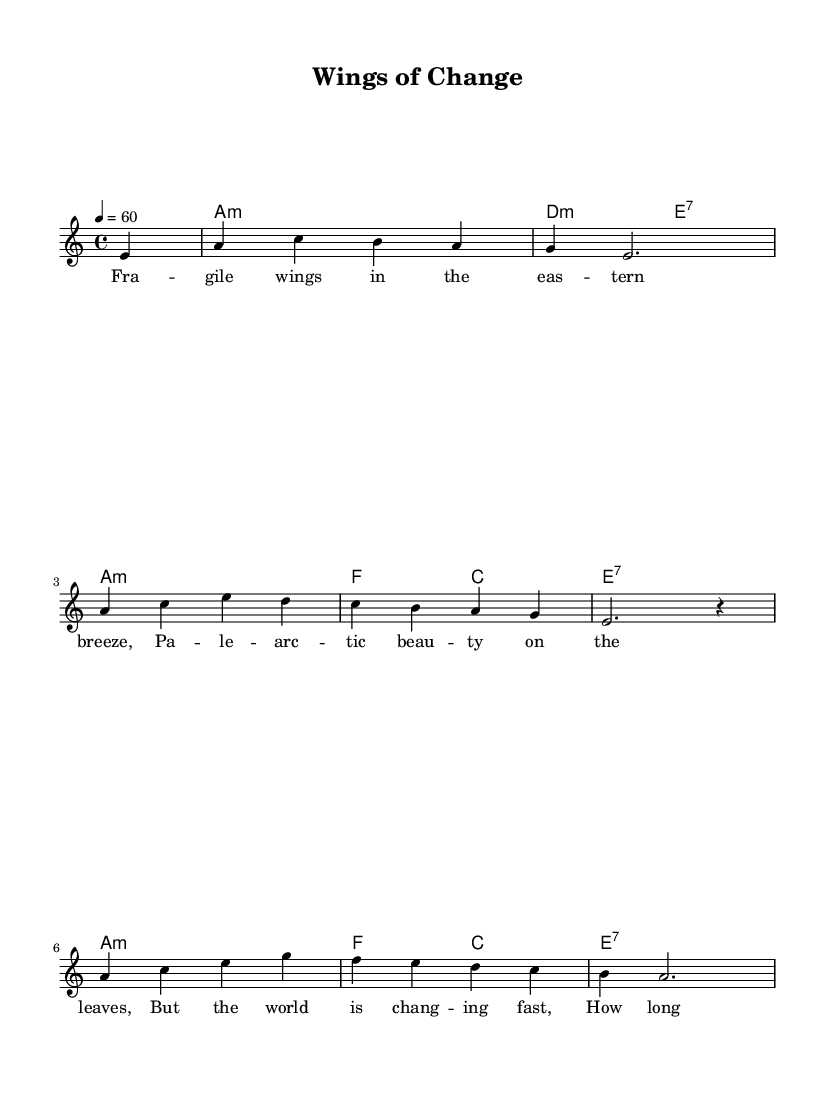What is the key signature of this music? The key signature can be determined from the information in the global section, which states "a minor." A minor has no sharps or flats in its key signature.
Answer: A minor What is the time signature of this music? The time signature is also given in the global information, which states "4/4." This means there are four beats in each measure, and the quarter note gets one beat.
Answer: 4/4 What is the tempo marking of this music? The tempo indication in the global section specifies "4 = 60," meaning that there are 60 beats per minute. This indicates a slow pace.
Answer: 60 How many measures are in the melody? Counting the musical phrases represented in the note patterns, the melody consists of eight measures in total.
Answer: 8 What is the structure of the lyrics in terms of lines? The provided lyrics section indicates that there are four lines of text, corresponding to the poetic structure of the ballad.
Answer: 4 lines How does the harmony change in the first half of the piece? Analyzing the harmony in the provided chord pattern, the first half alternates between two chords: A minor and D minor, establishing a somber tonality typical of blues music.
Answer: A minor to D minor 